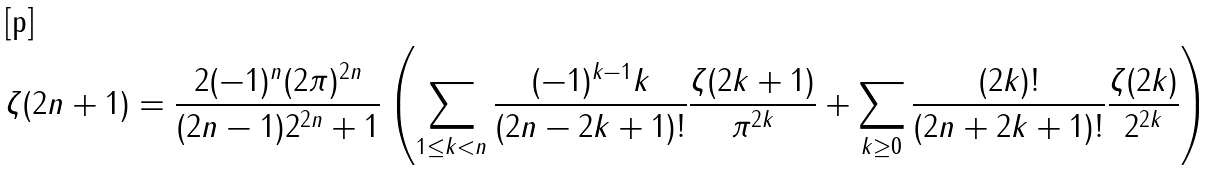<formula> <loc_0><loc_0><loc_500><loc_500>\zeta ( 2 n + 1 ) & = \frac { 2 ( - 1 ) ^ { n } ( 2 \pi ) ^ { 2 n } } { ( 2 n - 1 ) 2 ^ { 2 n } + 1 } \left ( \sum _ { 1 \leq k < n } \frac { ( - 1 ) ^ { k - 1 } k } { ( 2 n - 2 k + 1 ) ! } \frac { \zeta ( 2 k + 1 ) } { \pi ^ { 2 k } } + \sum _ { k \geq 0 } \frac { ( 2 k ) ! } { ( 2 n + 2 k + 1 ) ! } \frac { \zeta ( 2 k ) } { 2 ^ { 2 k } } \right )</formula> 